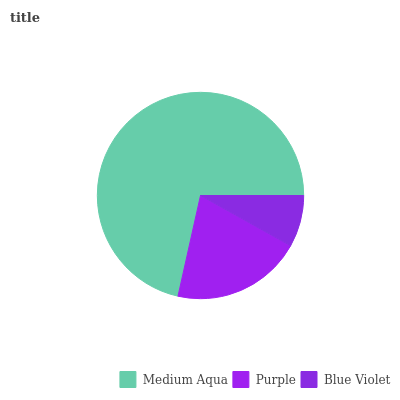Is Blue Violet the minimum?
Answer yes or no. Yes. Is Medium Aqua the maximum?
Answer yes or no. Yes. Is Purple the minimum?
Answer yes or no. No. Is Purple the maximum?
Answer yes or no. No. Is Medium Aqua greater than Purple?
Answer yes or no. Yes. Is Purple less than Medium Aqua?
Answer yes or no. Yes. Is Purple greater than Medium Aqua?
Answer yes or no. No. Is Medium Aqua less than Purple?
Answer yes or no. No. Is Purple the high median?
Answer yes or no. Yes. Is Purple the low median?
Answer yes or no. Yes. Is Blue Violet the high median?
Answer yes or no. No. Is Blue Violet the low median?
Answer yes or no. No. 